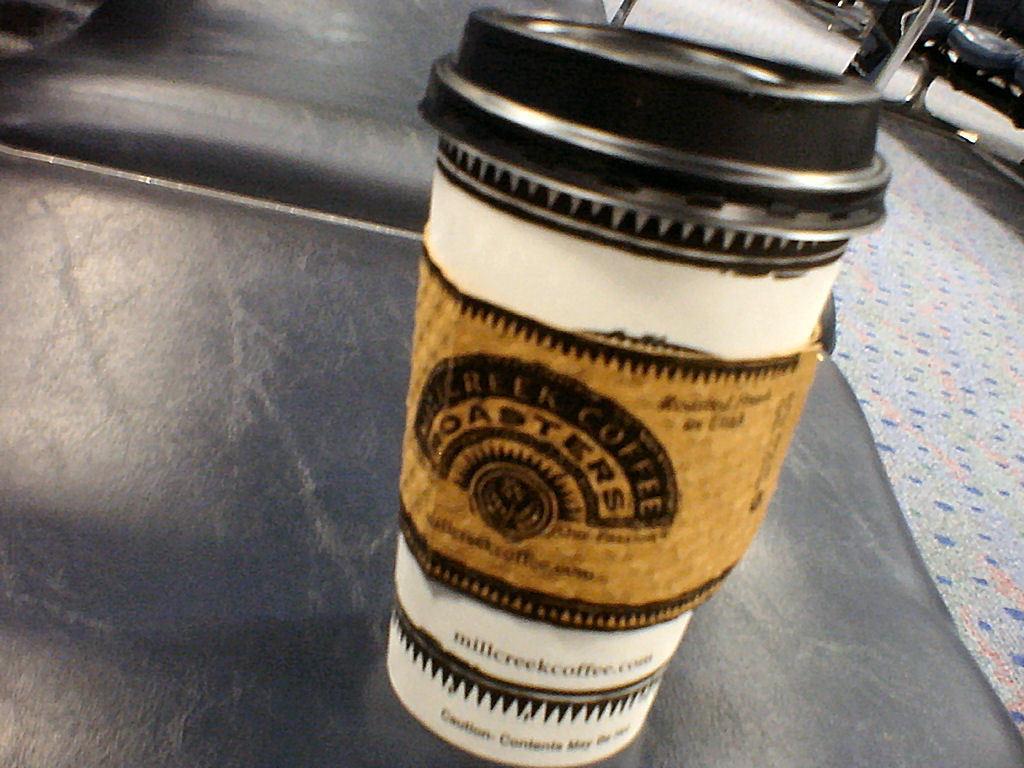How would you summarize this image in a sentence or two? In the center of the image, we can see a cup on the table and in the background, there are some objects and we can see a floor. 